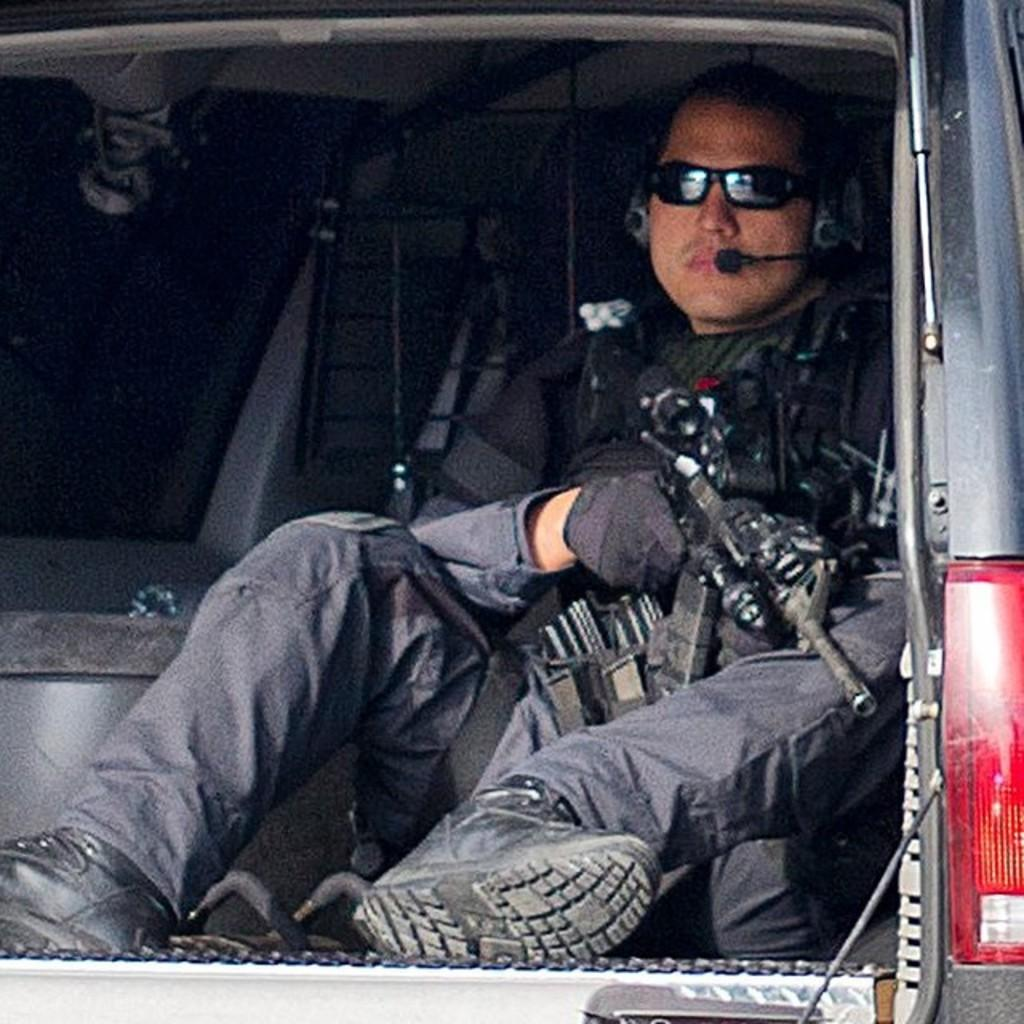What is the main subject of the image? The main subject of the image is a man. What is the man doing in the image? The man is sitting in a car. Can you describe the man's appearance in the image? The man is wearing glasses and earphones over his head. What is the man holding in the image? The man is holding a gun in his hands. What type of chicken can be seen in the image? There is no chicken present in the image. Is there any soap visible in the image? There is no soap visible in the image. 